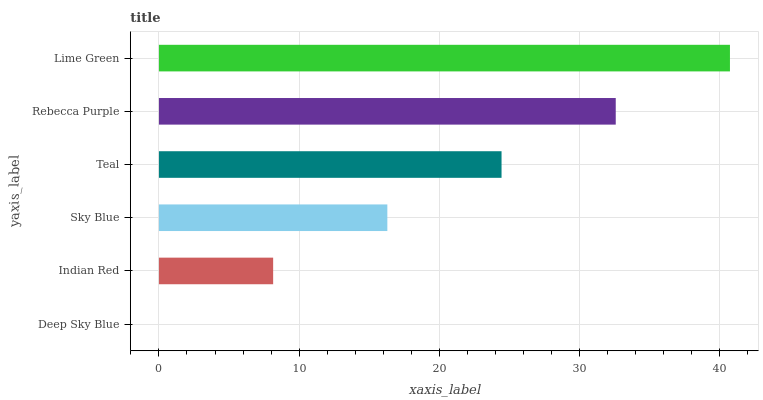Is Deep Sky Blue the minimum?
Answer yes or no. Yes. Is Lime Green the maximum?
Answer yes or no. Yes. Is Indian Red the minimum?
Answer yes or no. No. Is Indian Red the maximum?
Answer yes or no. No. Is Indian Red greater than Deep Sky Blue?
Answer yes or no. Yes. Is Deep Sky Blue less than Indian Red?
Answer yes or no. Yes. Is Deep Sky Blue greater than Indian Red?
Answer yes or no. No. Is Indian Red less than Deep Sky Blue?
Answer yes or no. No. Is Teal the high median?
Answer yes or no. Yes. Is Sky Blue the low median?
Answer yes or no. Yes. Is Sky Blue the high median?
Answer yes or no. No. Is Rebecca Purple the low median?
Answer yes or no. No. 